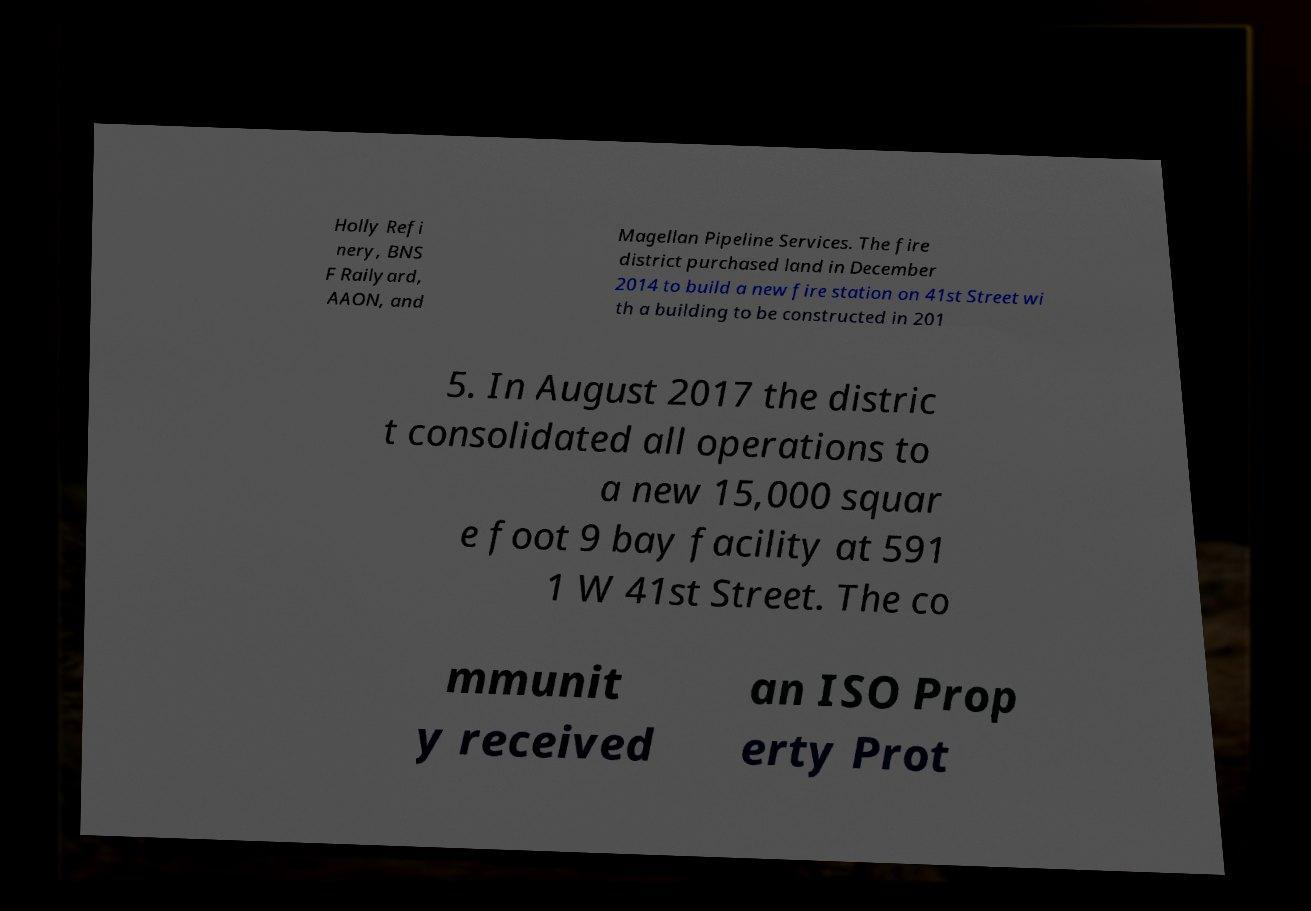What messages or text are displayed in this image? I need them in a readable, typed format. Holly Refi nery, BNS F Railyard, AAON, and Magellan Pipeline Services. The fire district purchased land in December 2014 to build a new fire station on 41st Street wi th a building to be constructed in 201 5. In August 2017 the distric t consolidated all operations to a new 15,000 squar e foot 9 bay facility at 591 1 W 41st Street. The co mmunit y received an ISO Prop erty Prot 